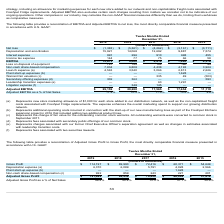From Freshpet's financial document, What financial items does EBITDA consist of as shown in the table? The document contains multiple relevant values: Net loss, Depreciation and amortization, Interest expense, Income tax expense. From the document: "Interest expense 991 296 910 698 455 a reconciliation of EBITDA and Adjusted EBITDA to net loss, the most directly comparable financial measure presen..." Also, What is the Adjusted EBITDA for each of the financial year ends shown in the table (in chronological order) respectively? The document contains multiple relevant values: $11,110, $17,654, $17,565, $20,280, $29,159 (in thousands). From the document: "sted EBITDA $ 29,159 $ 20,280 $ 17,565 $ 17,654 $ 11,110 Adjusted EBITDA $ 29,159 $ 20,280 $ 17,565 $ 17,654 $ 11,110 Adjusted EBITDA $ 29,159 $ 20,28..." Also, What was the EBITDA for each of the financial years ends listed shown in the table (in chronological order) respectively? The document contains multiple relevant values: $4,376, $7,490, $9,414, $9,080, $15,673 (in thousands). From the document: "EBITDA $ 15,673 $ 9,080 $ 9,414 $ 7,490 $ 4,376 EBITDA $ 15,673 $ 9,080 $ 9,414 $ 7,490 $ 4,376 EBITDA $ 15,673 $ 9,080 $ 9,414 $ 7,490 $ 4,376 EBITDA..." Also, can you calculate: What was the average EBITDA for 2018 and 2019? To answer this question, I need to perform calculations using the financial data. The calculation is: (15,673+9,080)/2, which equals 12376.5 (in thousands). This is based on the information: "EBITDA $ 15,673 $ 9,080 $ 9,414 $ 7,490 $ 4,376 EBITDA $ 15,673 $ 9,080 $ 9,414 $ 7,490 $ 4,376..." The key data points involved are: 15,673, 9,080. Also, can you calculate: What was the average adjusted EBITDA for 2018 and 2019? To answer this question, I need to perform calculations using the financial data. The calculation is: (29,159+20,280)/2, which equals 24719.5 (in thousands). This is based on the information: "Adjusted EBITDA $ 29,159 $ 20,280 $ 17,565 $ 17,654 $ 11,110 Adjusted EBITDA $ 29,159 $ 20,280 $ 17,565 $ 17,654 $ 11,110..." The key data points involved are: 20,280, 29,159. Also, can you calculate: What is the difference between average EBITDA and average adjusted EBITDA for 2018 and 2019? To answer this question, I need to perform calculations using the financial data. The calculation is: [(29,159+20,280)/2] - [(15,673+9,080)/2], which equals 12343 (in thousands). This is based on the information: "EBITDA $ 15,673 $ 9,080 $ 9,414 $ 7,490 $ 4,376 Adjusted EBITDA $ 29,159 $ 20,280 $ 17,565 $ 17,654 $ 11,110 EBITDA $ 15,673 $ 9,080 $ 9,414 $ 7,490 $ 4,376 Adjusted EBITDA $ 29,159 $ 20,280 $ 17,565 ..." The key data points involved are: 15,673, 20,280, 29,159. 